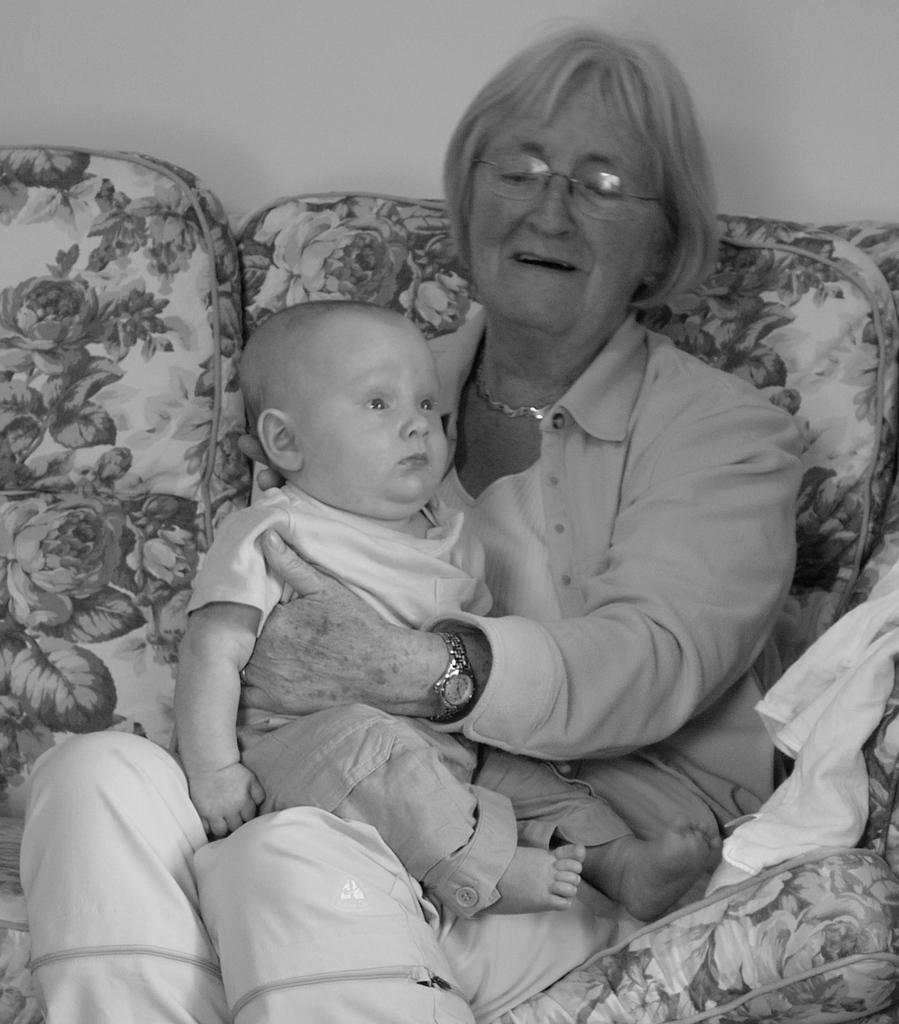What is the color scheme of the image? The image is black and white. Who is present in the image? There is a lady in the image. What accessories is the lady wearing? The lady is wearing glasses (specs) and a watch. What is the lady doing in the image? The lady is holding a baby and sitting on a sofa. What can be seen in the background of the image? There is a wall in the background of the image. How many cacti are present in the image? There are no cacti present in the image. What type of art is the lady creating in the image? There is no art creation activity depicted in the image. 